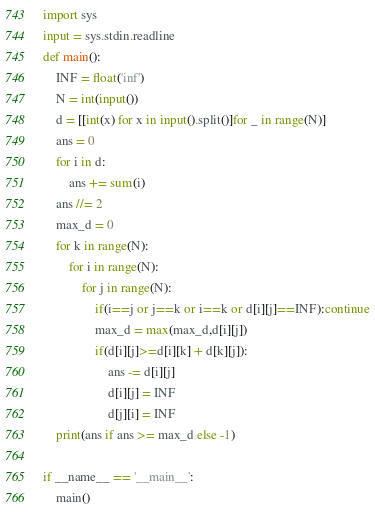Convert code to text. <code><loc_0><loc_0><loc_500><loc_500><_Python_>import sys
input = sys.stdin.readline
def main():
    INF = float('inf')
    N = int(input())
    d = [[int(x) for x in input().split()]for _ in range(N)]
    ans = 0
    for i in d:
        ans += sum(i)
    ans //= 2
    max_d = 0
    for k in range(N):
        for i in range(N):
            for j in range(N):
                if(i==j or j==k or i==k or d[i][j]==INF):continue
                max_d = max(max_d,d[i][j])
                if(d[i][j]>=d[i][k] + d[k][j]):
                    ans -= d[i][j]
                    d[i][j] = INF
                    d[j][i] = INF
    print(ans if ans >= max_d else -1)

if __name__ == '__main__':
    main()
</code> 